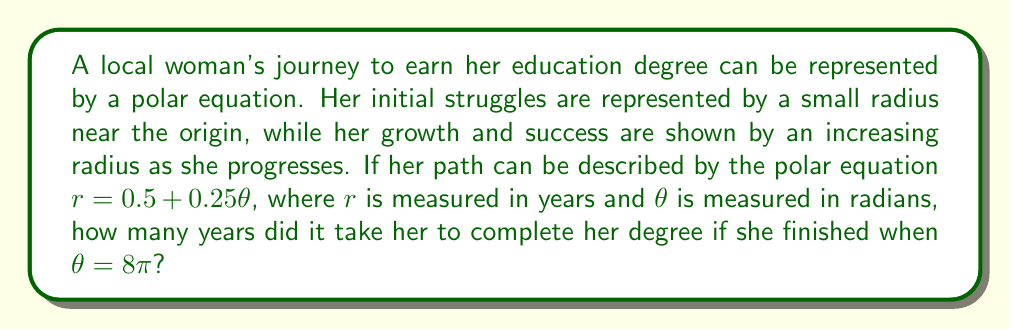Could you help me with this problem? To solve this problem, we need to follow these steps:

1) The given polar equation is $r = 0.5 + 0.25\theta$

2) We're told that the woman completes her degree when $\theta = 8\pi$

3) To find how long it took her to complete the degree, we need to calculate $r$ when $\theta = 8\pi$

4) Let's substitute $\theta = 8\pi$ into the equation:

   $r = 0.5 + 0.25(8\pi)$

5) Simplify:
   $r = 0.5 + 2\pi$

6) Calculate:
   $r = 0.5 + 2(3.14159...)$
   $r \approx 6.78$ years

7) Since we're dealing with years of education, it makes sense to round this to the nearest whole number.

Therefore, it took approximately 7 years for her to complete her degree.

[asy]
import graph;
size(200);
real r(real t) {return 0.5+0.25*t;}
draw(polargraph(r,0,8*pi,operator ..),blue);
draw(scale(0.5)*unitcircle, gray);
draw(scale(1)*unitcircle, gray);
draw(scale(1.5)*unitcircle, gray);
draw(scale(2)*unitcircle, gray);
for(int i=0; i<8; ++i) {
  draw((0,0)--(2*cos(i*pi/4),2*sin(i*pi/4)),gray);
}
label("Start",(0.5,0),E);
label("Finish",(r(8*pi)*cos(8*pi),r(8*pi)*sin(8*pi)),NE);
[/asy]
Answer: 7 years 